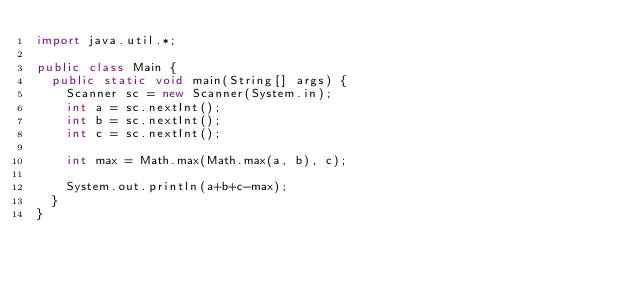<code> <loc_0><loc_0><loc_500><loc_500><_Java_>import java.util.*;

public class Main {
  public static void main(String[] args) {
    Scanner sc = new Scanner(System.in);
    int a = sc.nextInt();
    int b = sc.nextInt();
    int c = sc.nextInt();
    
    int max = Math.max(Math.max(a, b), c);
    
    System.out.println(a+b+c-max);
  }
}</code> 